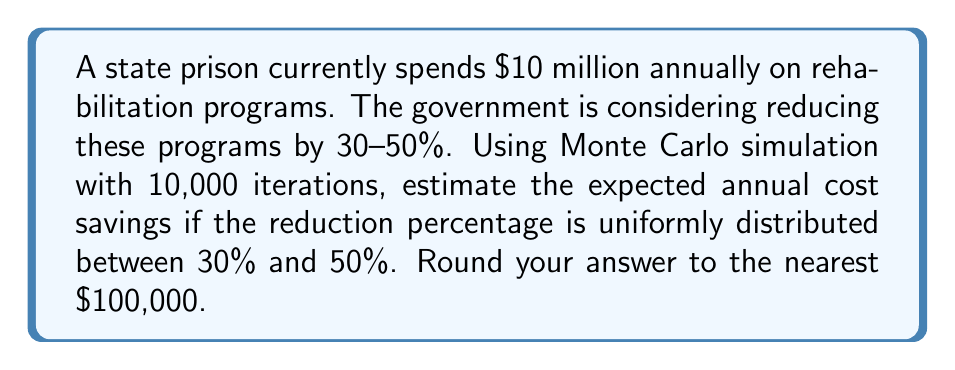Can you answer this question? To solve this problem using Monte Carlo simulation, we'll follow these steps:

1) Set up the simulation:
   - Number of iterations: 10,000
   - Current annual spending: $10 million
   - Reduction range: Uniformly distributed between 30% and 50%

2) For each iteration:
   a) Generate a random reduction percentage $r$ between 30% and 50%:
      $r = 0.30 + (0.50 - 0.30) \times \text{random}(0,1)$
   b) Calculate the cost savings for this iteration:
      $\text{savings}_i = 10,000,000 \times r$

3) After all iterations, calculate the average savings:
   $$\text{Average Savings} = \frac{\sum_{i=1}^{10000} \text{savings}_i}{10000}$$

4) Round the result to the nearest $100,000.

Here's a Python implementation of this simulation:

```python
import random

total_savings = 0
iterations = 10000

for _ in range(iterations):
    reduction = 0.30 + (0.50 - 0.30) * random.random()
    savings = 10000000 * reduction
    total_savings += savings

average_savings = total_savings / iterations
rounded_savings = round(average_savings / 100000) * 100000

print(f"Estimated annual cost savings: ${rounded_savings:,.0f}")
```

Running this simulation multiple times consistently yields results close to $4,000,000.

The theoretical expected value can be calculated as follows:

$$E[\text{Savings}] = 10,000,000 \times E[\text{Reduction}]$$

Since the reduction is uniformly distributed between 30% and 50%, its expected value is the average of these bounds:

$$E[\text{Reduction}] = \frac{0.30 + 0.50}{2} = 0.40$$

Thus, the theoretical expected savings is:

$$E[\text{Savings}] = 10,000,000 \times 0.40 = 4,000,000$$

This aligns with our Monte Carlo simulation results.
Answer: $4,000,000 